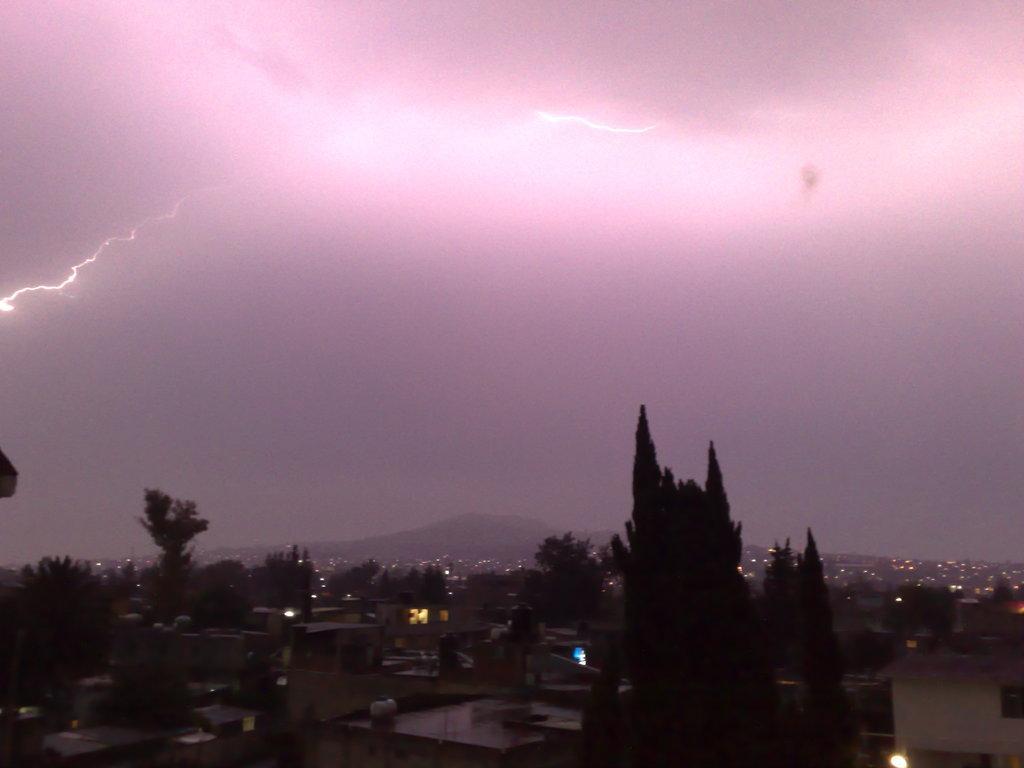Could you give a brief overview of what you see in this image? In this picture there are buildings and trees at the bottom side of the image and there is sky at the top side of the image. 